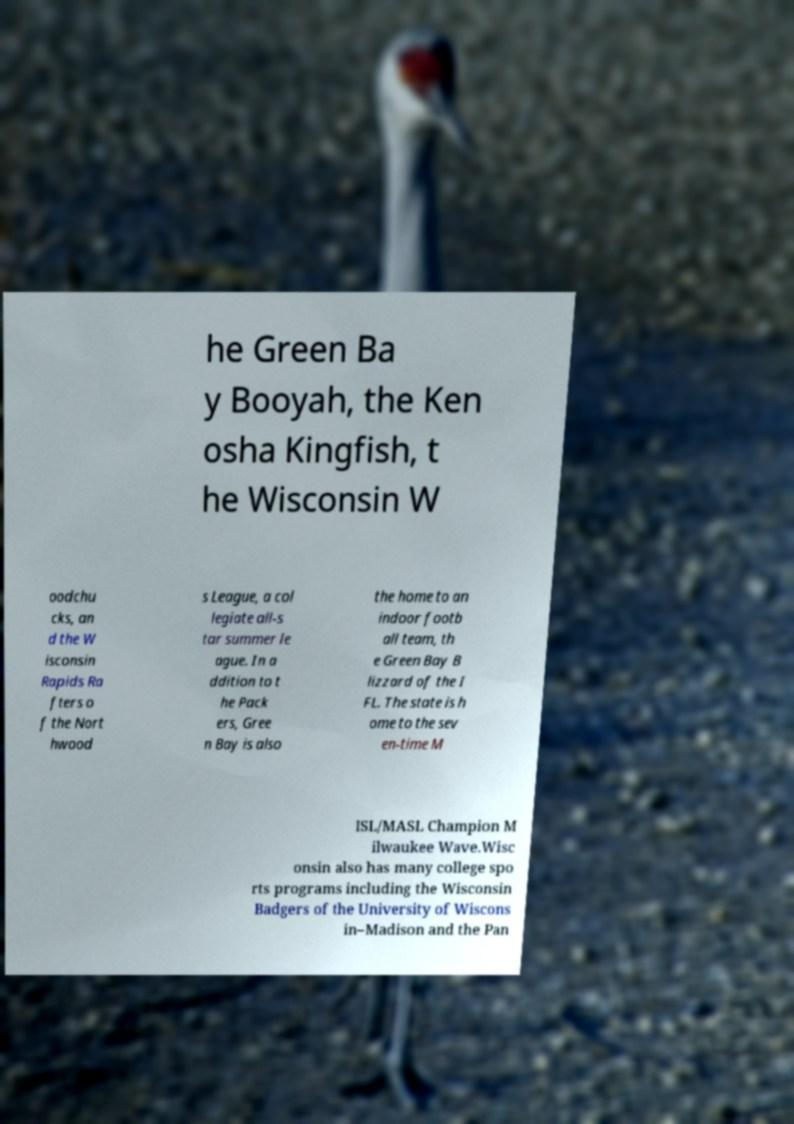Please identify and transcribe the text found in this image. he Green Ba y Booyah, the Ken osha Kingfish, t he Wisconsin W oodchu cks, an d the W isconsin Rapids Ra fters o f the Nort hwood s League, a col legiate all-s tar summer le ague. In a ddition to t he Pack ers, Gree n Bay is also the home to an indoor footb all team, th e Green Bay B lizzard of the I FL. The state is h ome to the sev en-time M ISL/MASL Champion M ilwaukee Wave.Wisc onsin also has many college spo rts programs including the Wisconsin Badgers of the University of Wiscons in–Madison and the Pan 